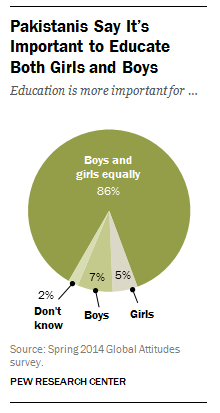Draw attention to some important aspects in this diagram. I have taken the sum of the three smallest segments, multiplied it by 5, and the result is not greater than the largest segment. Of the segments, three are smaller than 10%. 